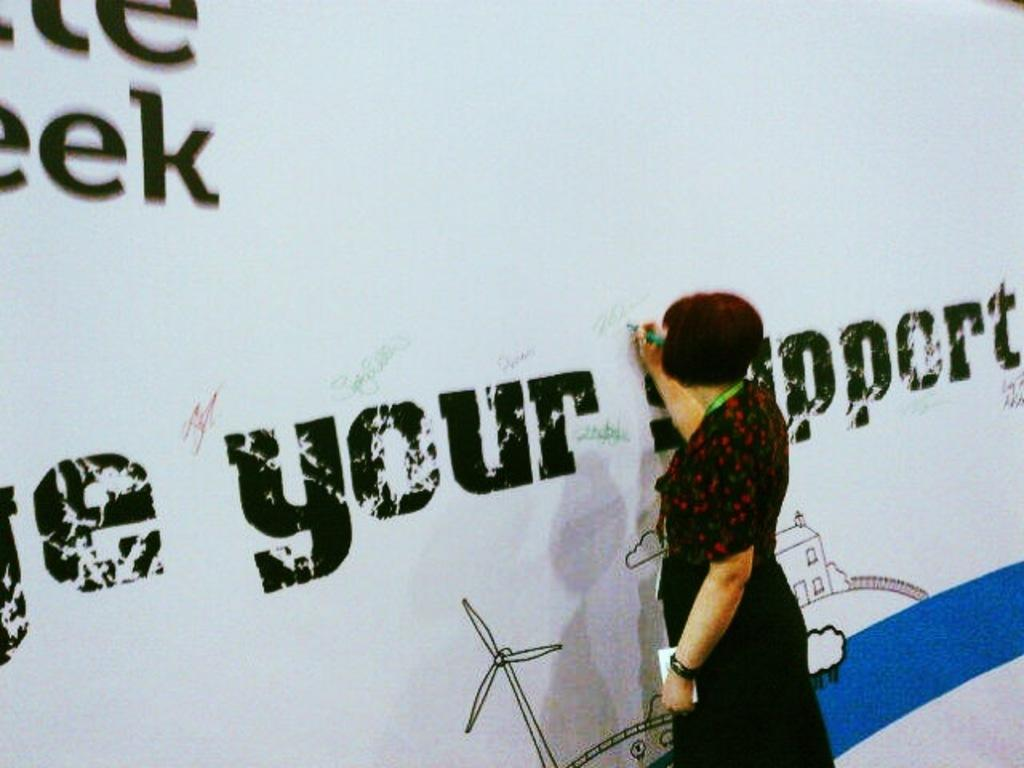What is the woman in the image holding? The woman is holding a pen and a paper. What is the woman doing with the pen and paper? The woman is likely writing or taking notes, as she is holding a pen. What is the woman's posture in the image? The woman is standing in the image. What can be seen at the top of the image? There is a banner with text at the top of the image. What does the woman's grandmother say about her mouth in the image? There is no mention of a grandmother or the woman's mouth in the image, so this question cannot be answered. 